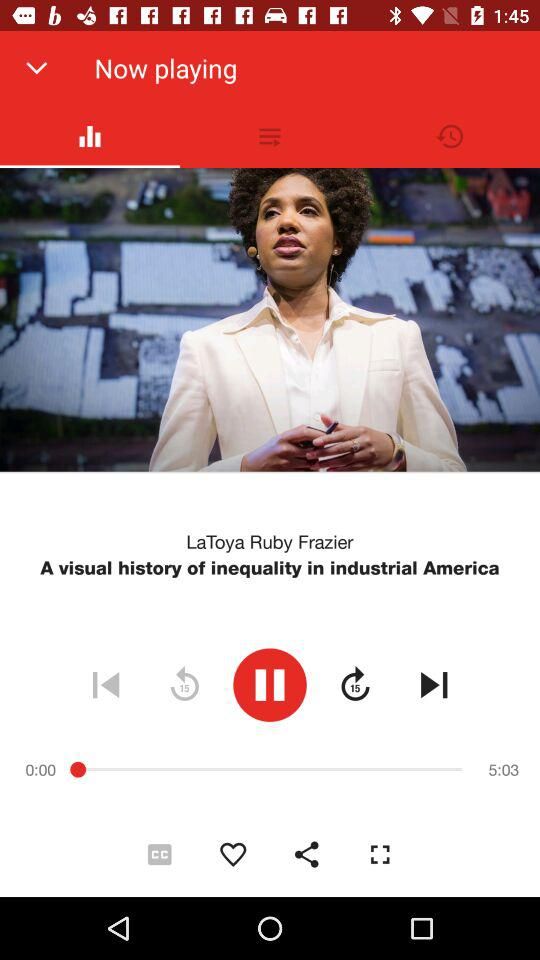What is the author name? The author name is LaToya Ruby Frazier. 